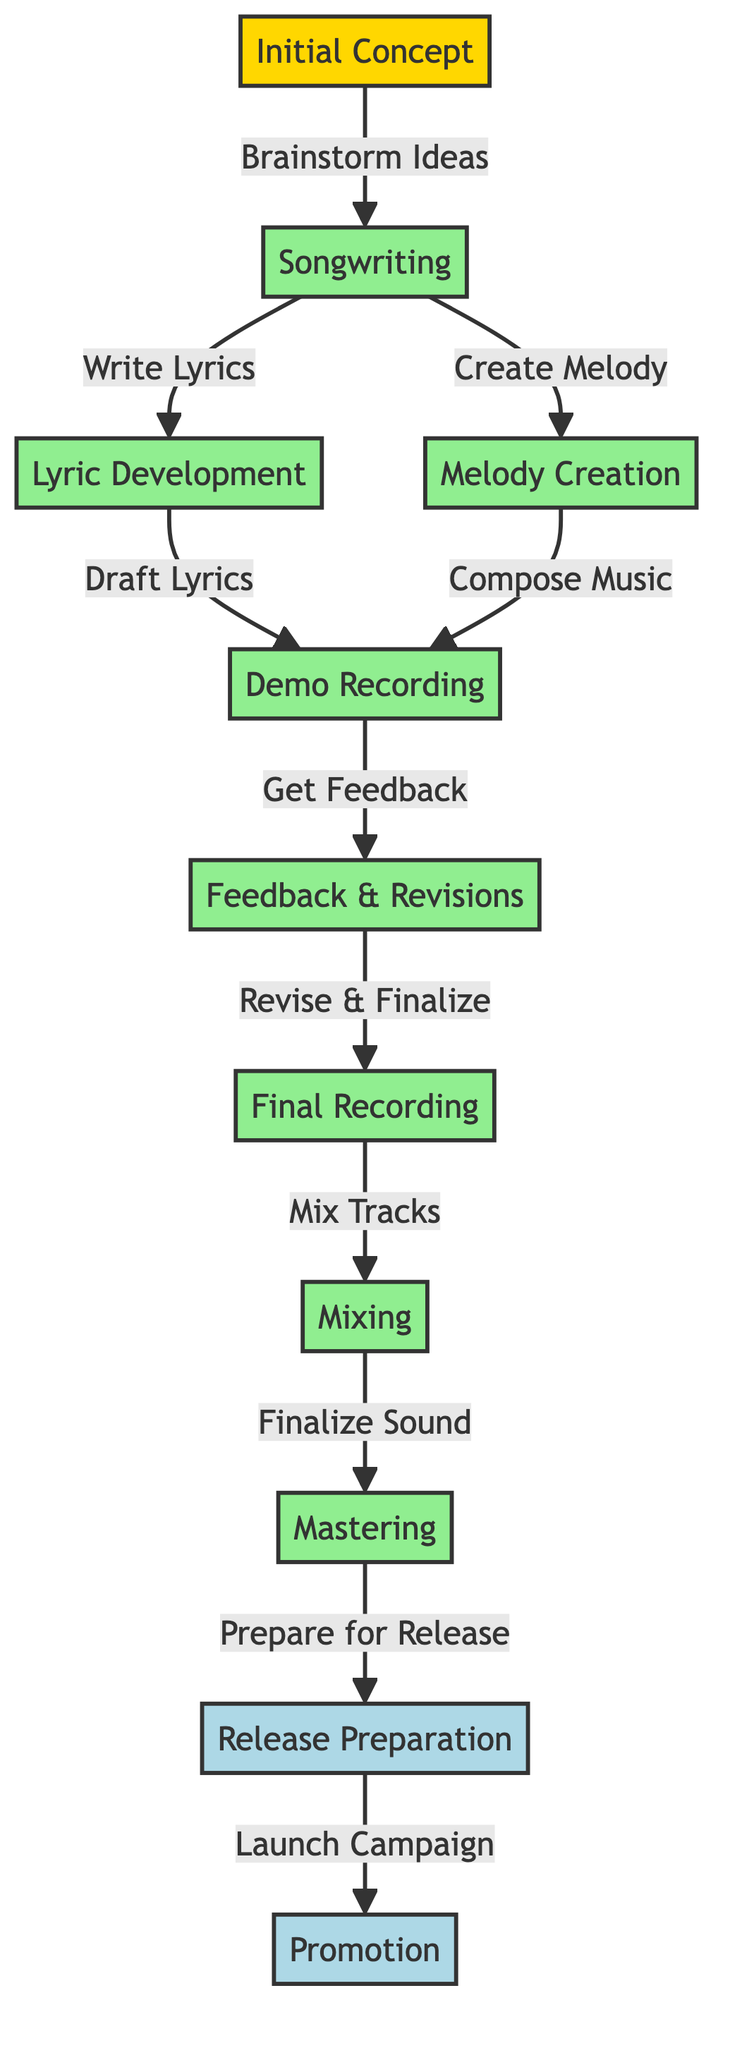What is the first step in the process? The first step is labeled as "Initial Concept" which is the starting point of the flowchart. It is clearly indicated at the top before all other steps follow.
Answer: Initial Concept How many processes are involved in the songwriting phase? The songwriting phase includes three distinct processes: "Songwriting," "Lyric Development," and "Melody Creation." Counting these steps gives us a total of three processes involved.
Answer: 3 What step comes after "Demo Recording"? From the flow of the diagram, the step that follows "Demo Recording" is "Feedback & Revisions," connecting these two steps directly with an arrow.
Answer: Feedback & Revisions Which final step involves a campaign? The final step that includes a campaign is "Promotion," as indicated in the flowchart, which comes after "Release Preparation."
Answer: Promotion What links "Mixing" and "Mastering"? The link between "Mixing" and "Mastering" is established through the "Finalize Sound" step that is positioned right after Mixing, indicating the sequential relationship between these two processes.
Answer: Finalize Sound What is the total number of steps in the diagram? The diagram consists of eleven nodes, including both processes and final steps, which can be counted directly from the visual layout.
Answer: 11 Which step involves drafting lyrics? The step where drafting lyrics occurs is "Lyric Development," which is specifically noted as part of the songwriting process.
Answer: Lyric Development What process happens just before "Final Recording"? The step that occurs just before "Final Recording" is "Feedback & Revisions," as indicated by the direct arrow pointing to the recording phase from the revisions step.
Answer: Feedback & Revisions Which part of the process is focused on getting feedback? The part focused on getting feedback is "Demo Recording," where feedback is solicited that leads to the revision of the demo.
Answer: Demo Recording 